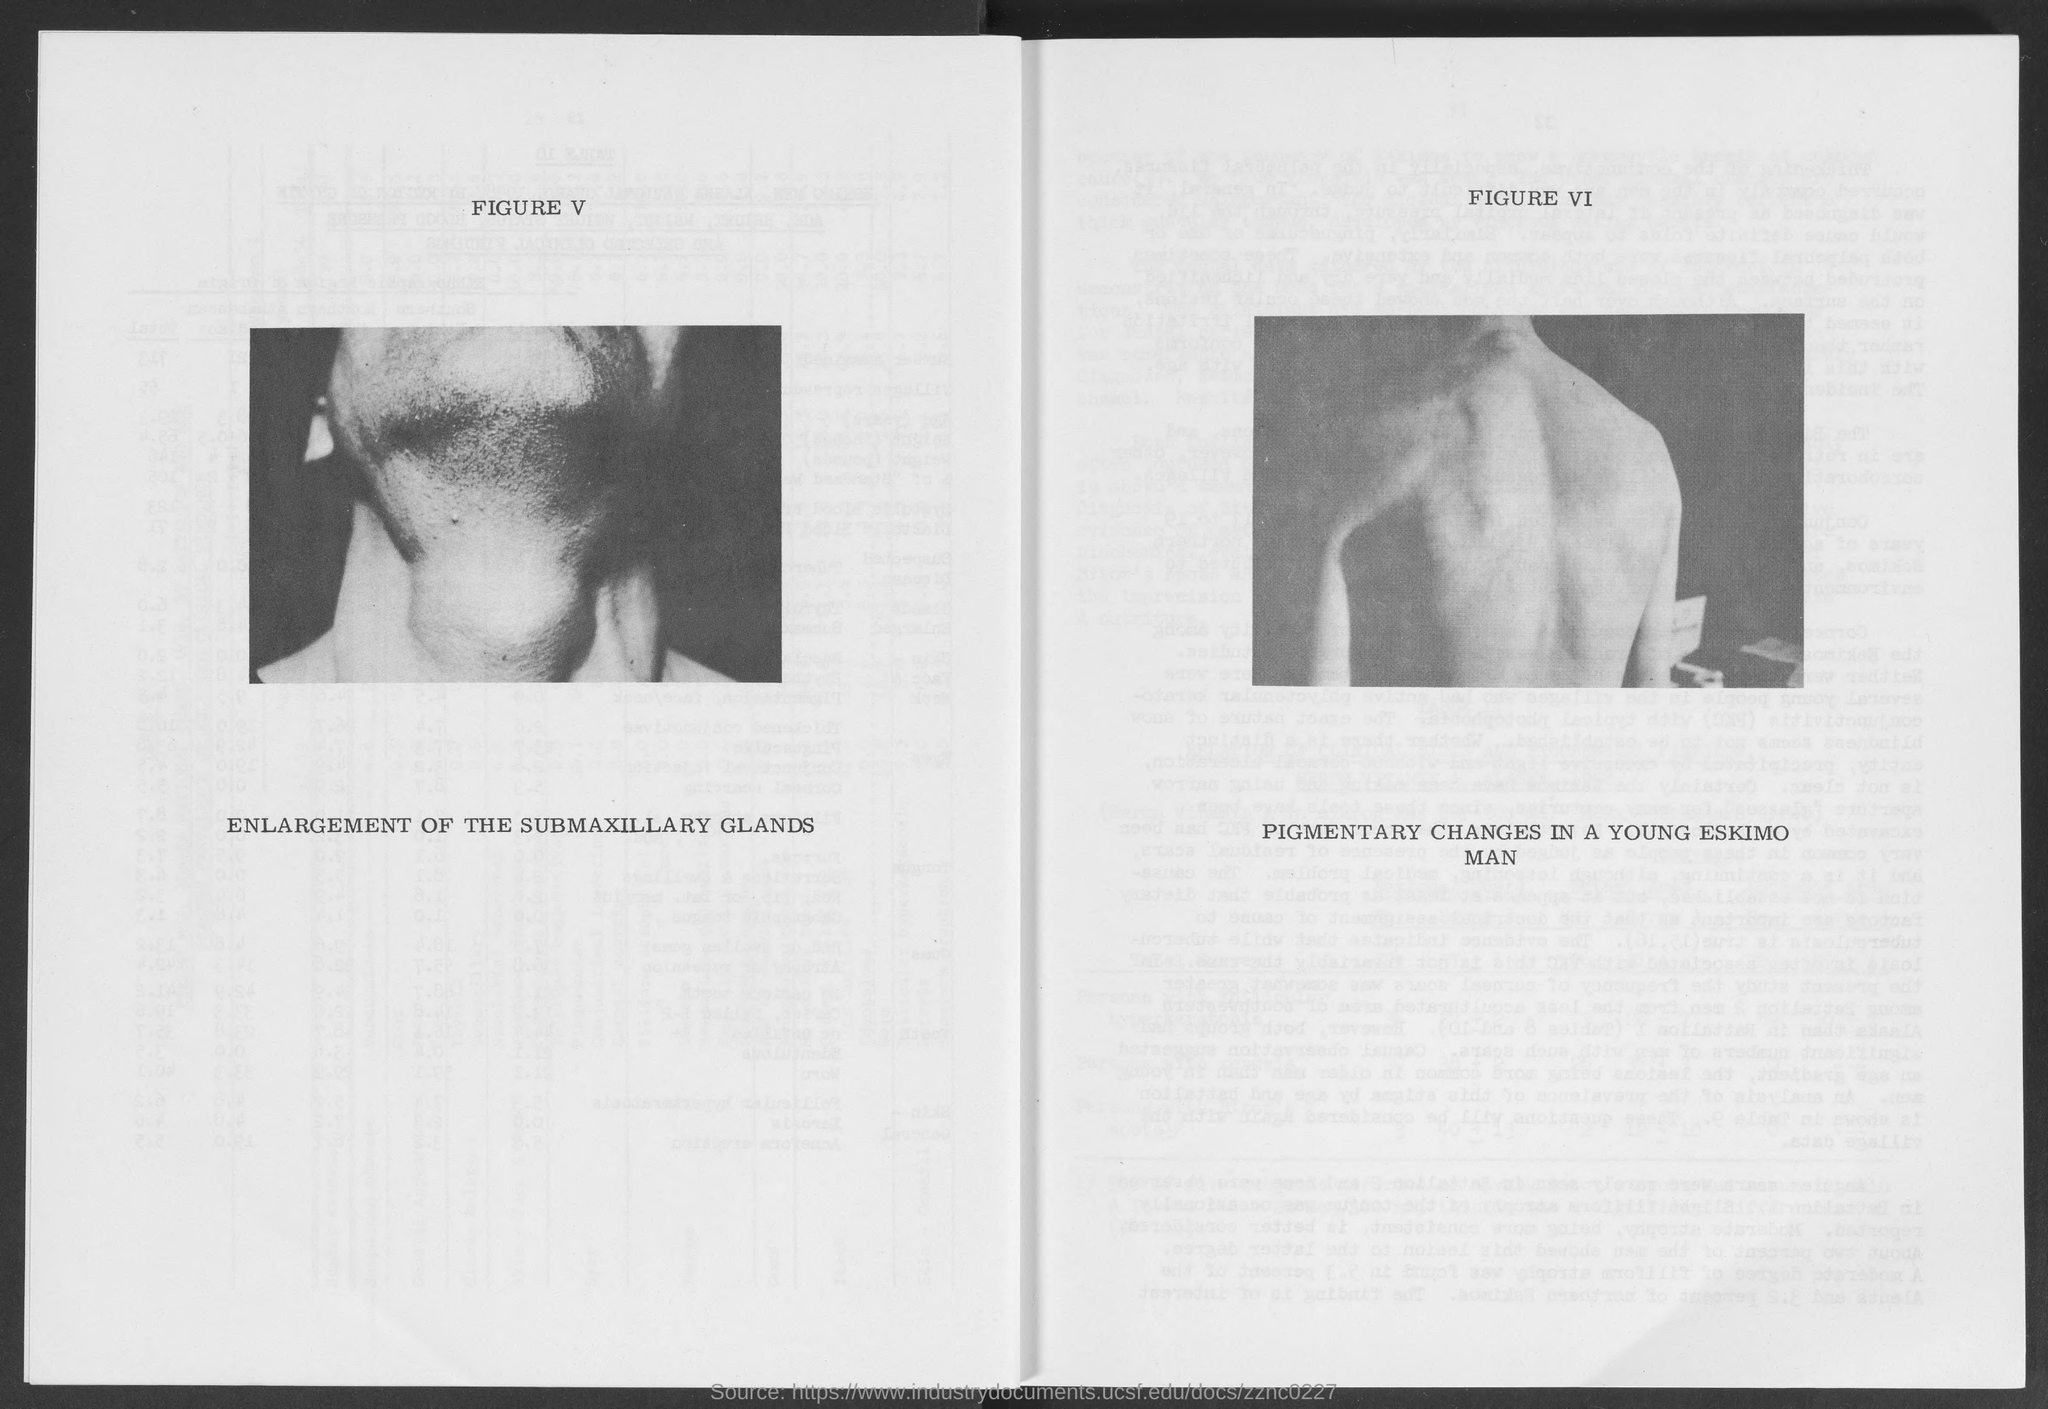What does FIGURE V  in this document describe?
Your answer should be very brief. ENLARGEMENT OF THE SUBMAXILLARY GLANDS. What does FIGURE VI  in this document describe?
Provide a short and direct response. Pigmentary changes in a young eskimo man. 